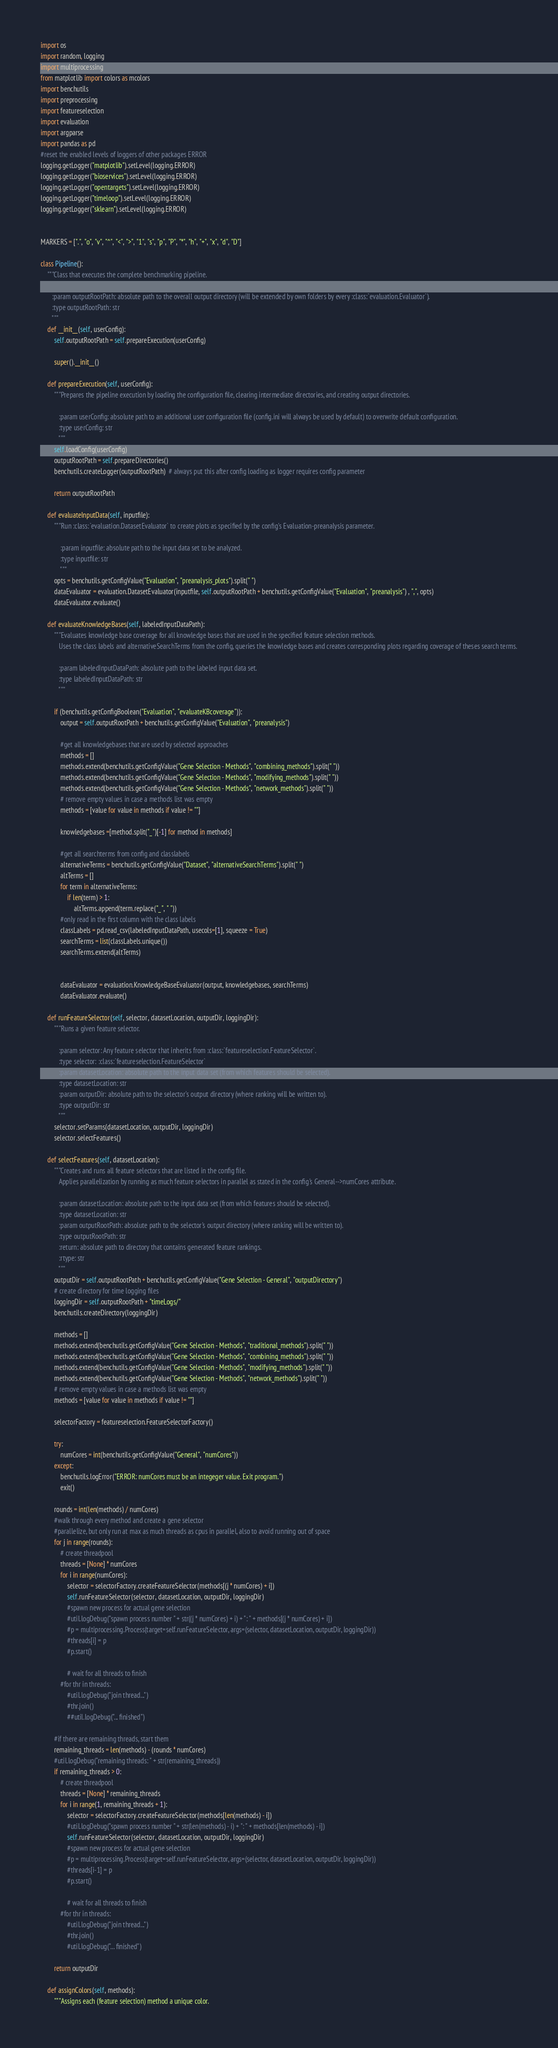<code> <loc_0><loc_0><loc_500><loc_500><_Python_>import os
import random, logging
import multiprocessing
from matplotlib import colors as mcolors
import benchutils
import preprocessing
import featureselection
import evaluation
import argparse
import pandas as pd
#reset the enabled levels of loggers of other packages ERROR
logging.getLogger("matplotlib").setLevel(logging.ERROR)
logging.getLogger("bioservices").setLevel(logging.ERROR)
logging.getLogger("opentargets").setLevel(logging.ERROR)
logging.getLogger("timeloop").setLevel(logging.ERROR)
logging.getLogger("sklearn").setLevel(logging.ERROR)


MARKERS = [".", "o", "v", "^", "<", ">", "1", "s", "p", "P", "*", "h", "+", "x", "d", "D"]

class Pipeline():
    """Class that executes the complete benchmarking pipeline.

       :param outputRootPath: absolute path to the overall output directory (will be extended by own folders by every :class:`evaluation.Evaluator`).
       :type outputRootPath: str
       """
    def __init__(self, userConfig):
        self.outputRootPath = self.prepareExecution(userConfig)

        super().__init__()

    def prepareExecution(self, userConfig):
        """Prepares the pipeline execution by loading the configuration file, clearing intermediate directories, and creating output directories.

           :param userConfig: absolute path to an additional user configuration file (config.ini will always be used by default) to overwrite default configuration.
           :type userConfig: str
           """
        self.loadConfig(userConfig)
        outputRootPath = self.prepareDirectories()
        benchutils.createLogger(outputRootPath)  # always put this after config loading as logger requires config parameter

        return outputRootPath

    def evaluateInputData(self, inputfile):
        """Run :class:`evaluation.DatasetEvaluator` to create plots as specified by the config's Evaluation-preanalysis parameter.

            :param inputfile: absolute path to the input data set to be analyzed.
            :type inputfile: str
            """
        opts = benchutils.getConfigValue("Evaluation", "preanalysis_plots").split(" ")
        dataEvaluator = evaluation.DatasetEvaluator(inputfile, self.outputRootPath + benchutils.getConfigValue("Evaluation", "preanalysis") , ",", opts)
        dataEvaluator.evaluate()

    def evaluateKnowledgeBases(self, labeledInputDataPath):
        """Evaluates knowledge base coverage for all knowledge bases that are used in the specified feature selection methods.
           Uses the class labels and alternativeSearchTerms from the config, queries the knowledge bases and creates corresponding plots regarding coverage of theses search terms.

           :param labeledInputDataPath: absolute path to the labeled input data set.
           :type labeledInputDataPath: str
           """

        if (benchutils.getConfigBoolean("Evaluation", "evaluateKBcoverage")):
            output = self.outputRootPath + benchutils.getConfigValue("Evaluation", "preanalysis")

            #get all knowledgebases that are used by selected approaches
            methods = []
            methods.extend(benchutils.getConfigValue("Gene Selection - Methods", "combining_methods").split(" "))
            methods.extend(benchutils.getConfigValue("Gene Selection - Methods", "modifying_methods").split(" "))
            methods.extend(benchutils.getConfigValue("Gene Selection - Methods", "network_methods").split(" "))
            # remove empty values in case a methods list was empty
            methods = [value for value in methods if value != ""]

            knowledgebases =[method.split("_")[-1] for method in methods]

            #get all searchterms from config and classlabels
            alternativeTerms = benchutils.getConfigValue("Dataset", "alternativeSearchTerms").split(" ")
            altTerms = []
            for term in alternativeTerms:
                if len(term) > 1:
                    altTerms.append(term.replace("_", " "))
            #only read in the first column with the class labels
            classLabels = pd.read_csv(labeledInputDataPath, usecols=[1], squeeze = True)
            searchTerms = list(classLabels.unique())
            searchTerms.extend(altTerms)


            dataEvaluator = evaluation.KnowledgeBaseEvaluator(output, knowledgebases, searchTerms)
            dataEvaluator.evaluate()

    def runFeatureSelector(self, selector, datasetLocation, outputDir, loggingDir):
        """Runs a given feature selector.

           :param selector: Any feature selector that inherits from :class:`featureselection.FeatureSelector`.
           :type selector: :class:`featureselection.FeatureSelector`
           :param datasetLocation: absolute path to the input data set (from which features should be selected).
           :type datasetLocation: str
           :param outputDir: absolute path to the selector's output directory (where ranking will be written to).
           :type outputDir: str
           """
        selector.setParams(datasetLocation, outputDir, loggingDir)
        selector.selectFeatures()

    def selectFeatures(self, datasetLocation):
        """Creates and runs all feature selectors that are listed in the config file.
           Applies parallelization by running as much feature selectors in parallel as stated in the config's General-->numCores attribute.

           :param datasetLocation: absolute path to the input data set (from which features should be selected).
           :type datasetLocation: str
           :param outputRootPath: absolute path to the selector's output directory (where ranking will be written to).
           :type outputRootPath: str
           :return: absolute path to directory that contains generated feature rankings.
           :rtype: str
           """
        outputDir = self.outputRootPath + benchutils.getConfigValue("Gene Selection - General", "outputDirectory")
        # create directory for time logging files
        loggingDir = self.outputRootPath + "timeLogs/"
        benchutils.createDirectory(loggingDir)

        methods = []
        methods.extend(benchutils.getConfigValue("Gene Selection - Methods", "traditional_methods").split(" "))
        methods.extend(benchutils.getConfigValue("Gene Selection - Methods", "combining_methods").split(" "))
        methods.extend(benchutils.getConfigValue("Gene Selection - Methods", "modifying_methods").split(" "))
        methods.extend(benchutils.getConfigValue("Gene Selection - Methods", "network_methods").split(" "))
        # remove empty values in case a methods list was empty
        methods = [value for value in methods if value != ""]

        selectorFactory = featureselection.FeatureSelectorFactory()

        try:
            numCores = int(benchutils.getConfigValue("General", "numCores"))
        except:
            benchutils.logError("ERROR: numCores must be an integeger value. Exit program.")
            exit()

        rounds = int(len(methods) / numCores)
        #walk through every method and create a gene selector
        #parallelize, but only run at max as much threads as cpus in parallel, also to avoid running out of space
        for j in range(rounds):
            # create threadpool
            threads = [None] * numCores
            for i in range(numCores):
                selector = selectorFactory.createFeatureSelector(methods[(j * numCores) + i])
                self.runFeatureSelector(selector, datasetLocation, outputDir, loggingDir)
                #spawn new process for actual gene selection
                #util.logDebug("spawn process number " + str((j * numCores) + i) + ": " + methods[(j * numCores) + i])
                #p = multiprocessing.Process(target=self.runFeatureSelector, args=(selector, datasetLocation, outputDir, loggingDir))
                #threads[i] = p
                #p.start()

                # wait for all threads to finish
            #for thr in threads:
                #util.logDebug("join thread...")
                #thr.join()
                ##util.logDebug("... finished")

        #if there are remaining threads, start them
        remaining_threads = len(methods) - (rounds * numCores)
        #util.logDebug("remaining threads: " + str(remaining_threads))
        if remaining_threads > 0:
            # create threadpool
            threads = [None] * remaining_threads
            for i in range(1, remaining_threads + 1):
                selector = selectorFactory.createFeatureSelector(methods[len(methods) - i])
                #util.logDebug("spawn process number " + str(len(methods) - i) + ": " + methods[len(methods) - i])
                self.runFeatureSelector(selector, datasetLocation, outputDir, loggingDir)
                #spawn new process for actual gene selection
                #p = multiprocessing.Process(target=self.runFeatureSelector, args=(selector, datasetLocation, outputDir, loggingDir))
                #threads[i-1] = p
                #p.start()

                # wait for all threads to finish
            #for thr in threads:
                #util.logDebug("join thread...")
                #thr.join()
                #util.logDebug("... finished")

        return outputDir

    def assignColors(self, methods):
        """Assigns each (feature selection) method a unique color.</code> 